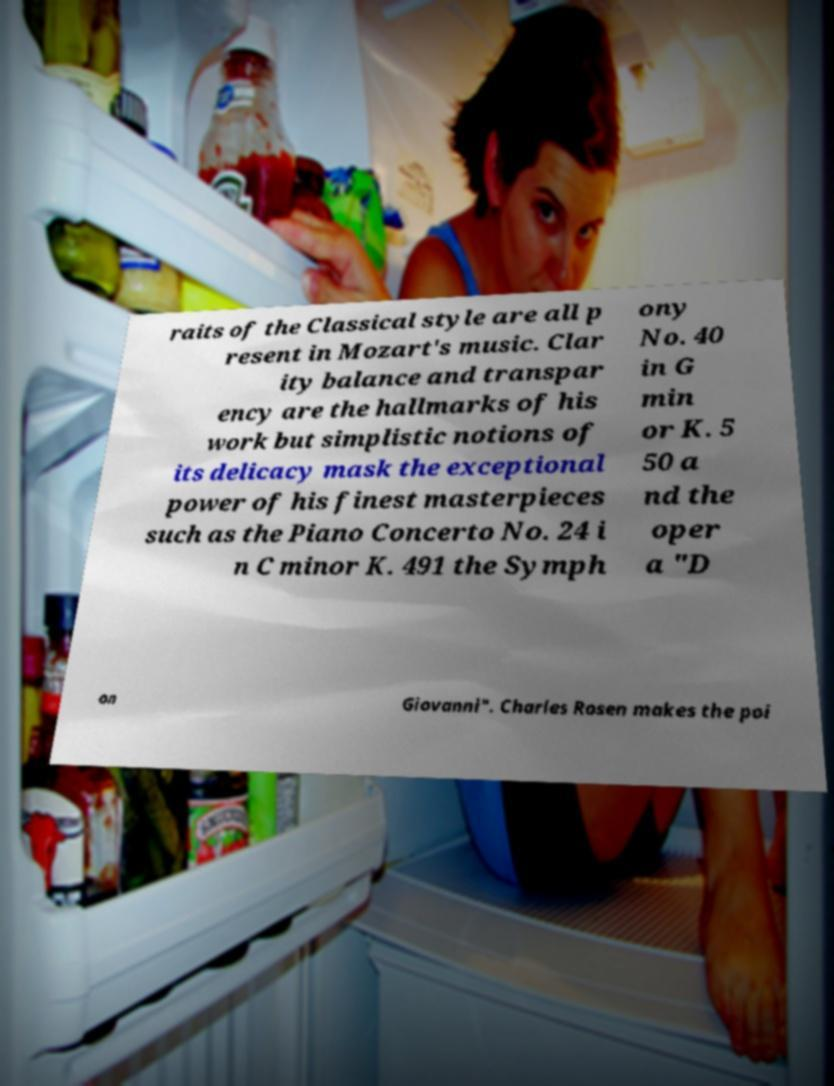What messages or text are displayed in this image? I need them in a readable, typed format. raits of the Classical style are all p resent in Mozart's music. Clar ity balance and transpar ency are the hallmarks of his work but simplistic notions of its delicacy mask the exceptional power of his finest masterpieces such as the Piano Concerto No. 24 i n C minor K. 491 the Symph ony No. 40 in G min or K. 5 50 a nd the oper a "D on Giovanni". Charles Rosen makes the poi 